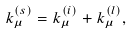<formula> <loc_0><loc_0><loc_500><loc_500>k ^ { ( s ) } _ { \mu } = k ^ { ( i ) } _ { \mu } + k ^ { ( l ) } _ { \mu } ,</formula> 